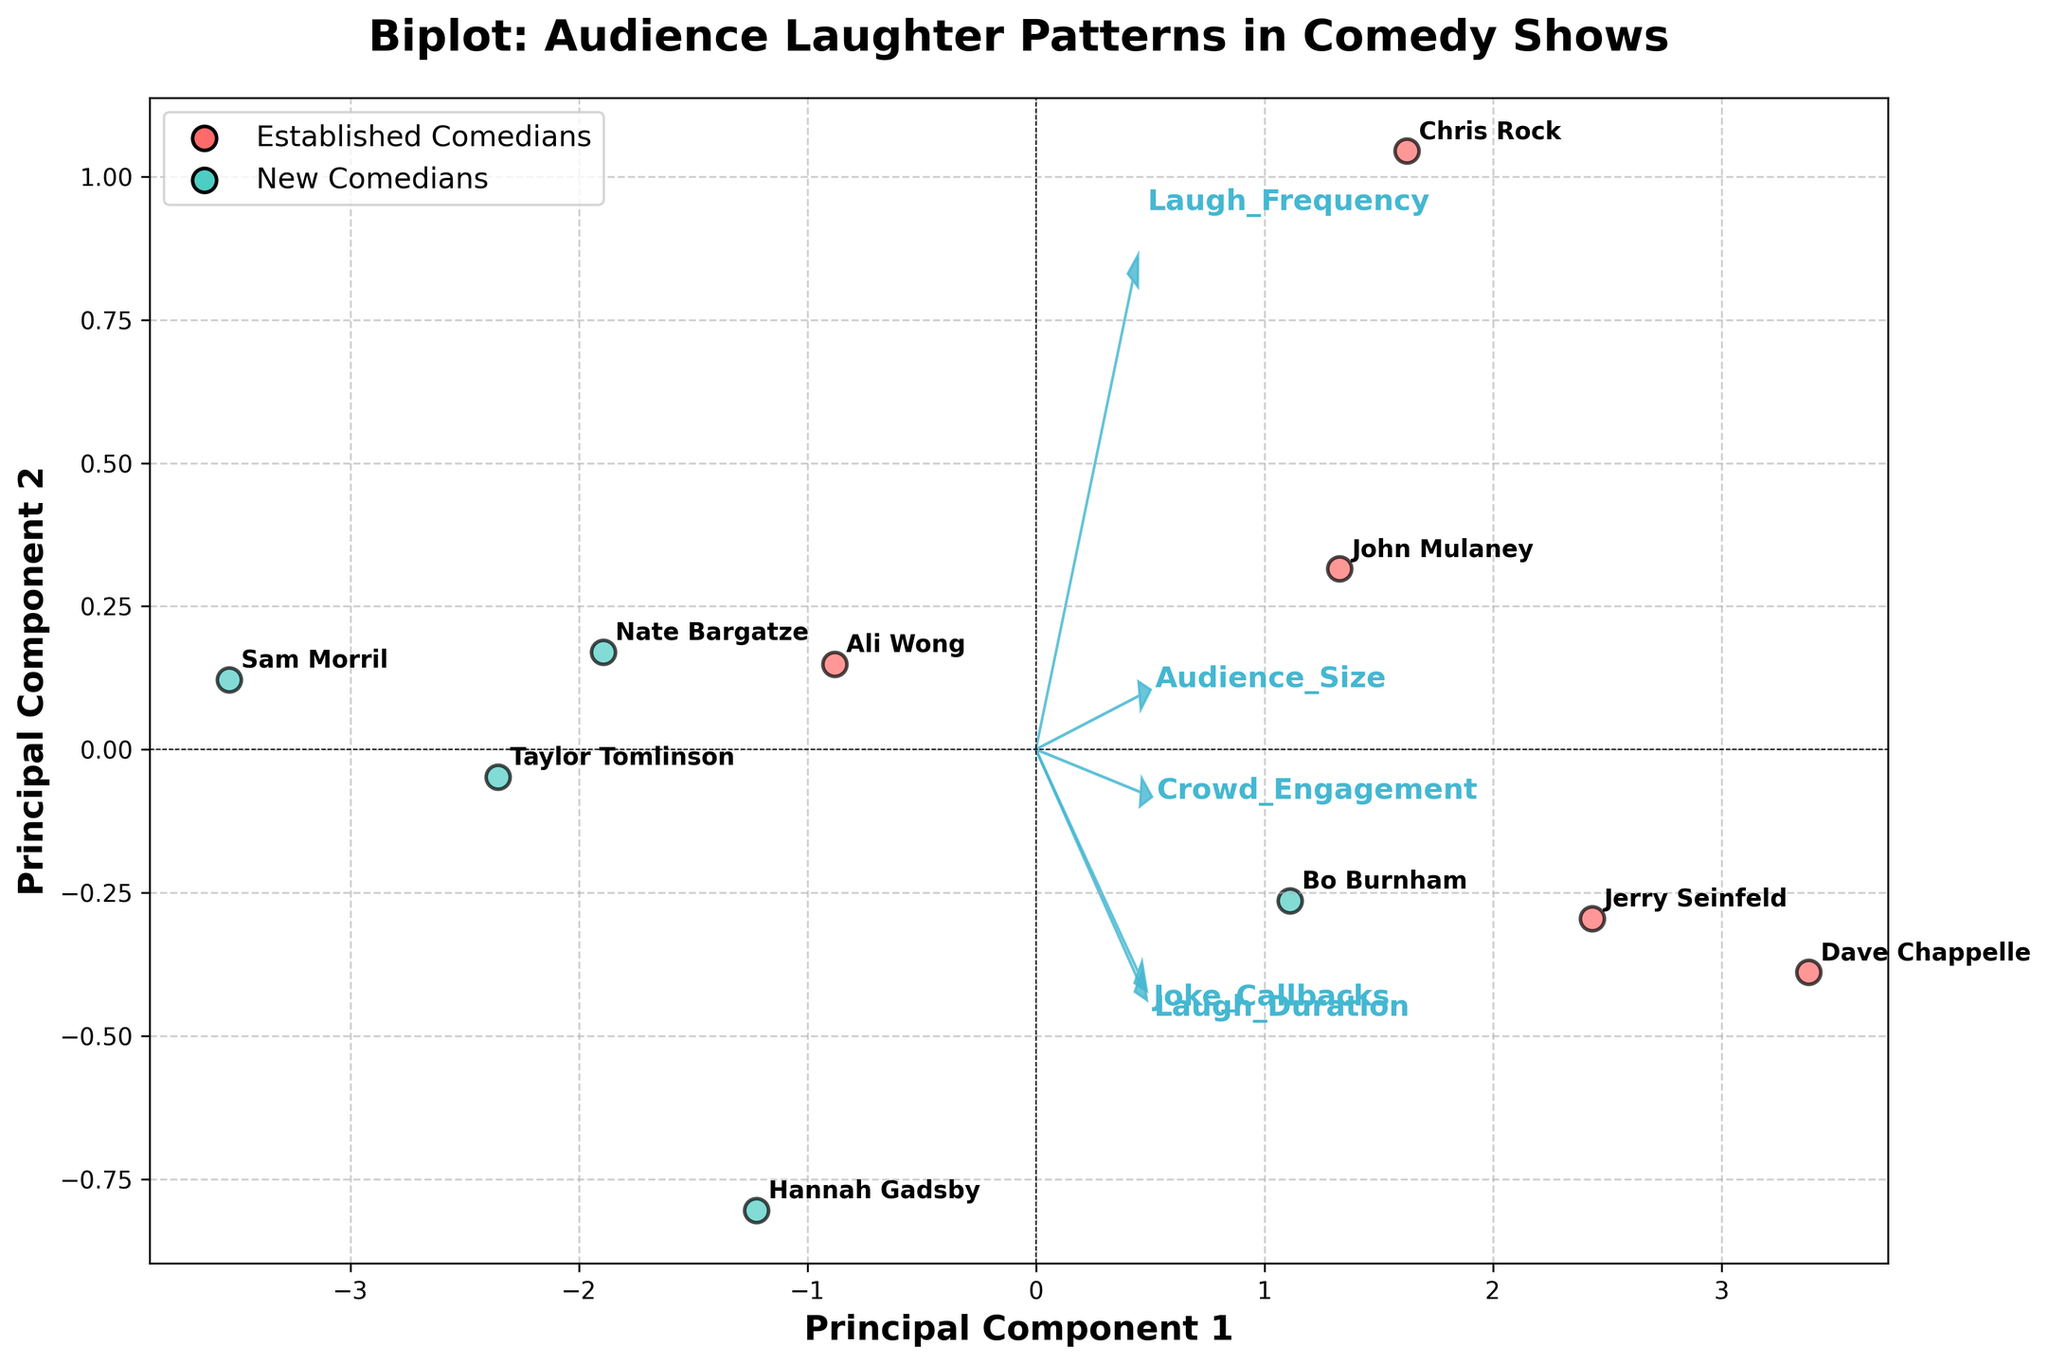How many comedians are plotted in the biplot? Count the number of data points (with comedian names) displayed on the plot.
Answer: 10 Which comedians are considered established in the plot? Look for the comedians whose data points are colored differently and labeled in the legend as "Established Comedians."
Answer: Jerry Seinfeld, Chris Rock, Dave Chappelle, Ali Wong, John Mulaney Where are the new comedians mostly located in terms of Principal Component 1 and 2 axes? Identify the clustering of data points colored differently for "New Comedians" and observe their positions relative to the Principal Component 1 and 2 axes.
Answer: More scattered but mostly on the left side of the Principal Component 1 axis Which feature appears to have the highest influence on Principal Component 1? Observe the feature vectors and determine which arrow extends furthest along the Principal Component 1 axis.
Answer: Laugh Frequency How do established comedians compare to new comedians in terms of Crowd Engagement? Compare the positions of the two groups along the feature vector for Crowd Engagement.
Answer: Established comedians generally show higher Crowd Engagement Are there any comedians whose data points are close to the origin of the plot? If yes, name them. Identify any data points that are near the intersection of the axes.
Answer: No, all comedians' data points are relatively distant from the origin Which comedian has the highest Laugh Duration among new comedians, based on the plot? Look for the new comedian's data point that is further along the Laugh Duration vector.
Answer: Taylor Tomlinson Which feature seems to least influence Principal Component 2? Observe the feature vectors and see which arrow has the smallest projection on the Principal Component 2 axis.
Answer: Joke Callbacks 